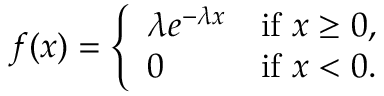Convert formula to latex. <formula><loc_0><loc_0><loc_500><loc_500>f ( x ) = { \left \{ \begin{array} { l l } { \lambda e ^ { - \lambda x } } & { { i f } x \geq 0 , } \\ { 0 } & { { i f } x < 0 . } \end{array} }</formula> 